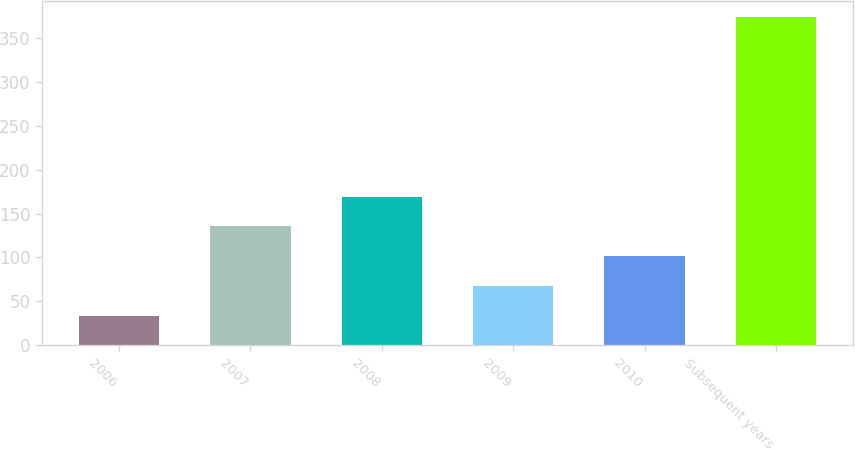Convert chart. <chart><loc_0><loc_0><loc_500><loc_500><bar_chart><fcel>2006<fcel>2007<fcel>2008<fcel>2009<fcel>2010<fcel>Subsequent years<nl><fcel>33<fcel>135.3<fcel>169.4<fcel>67.1<fcel>101.2<fcel>374<nl></chart> 